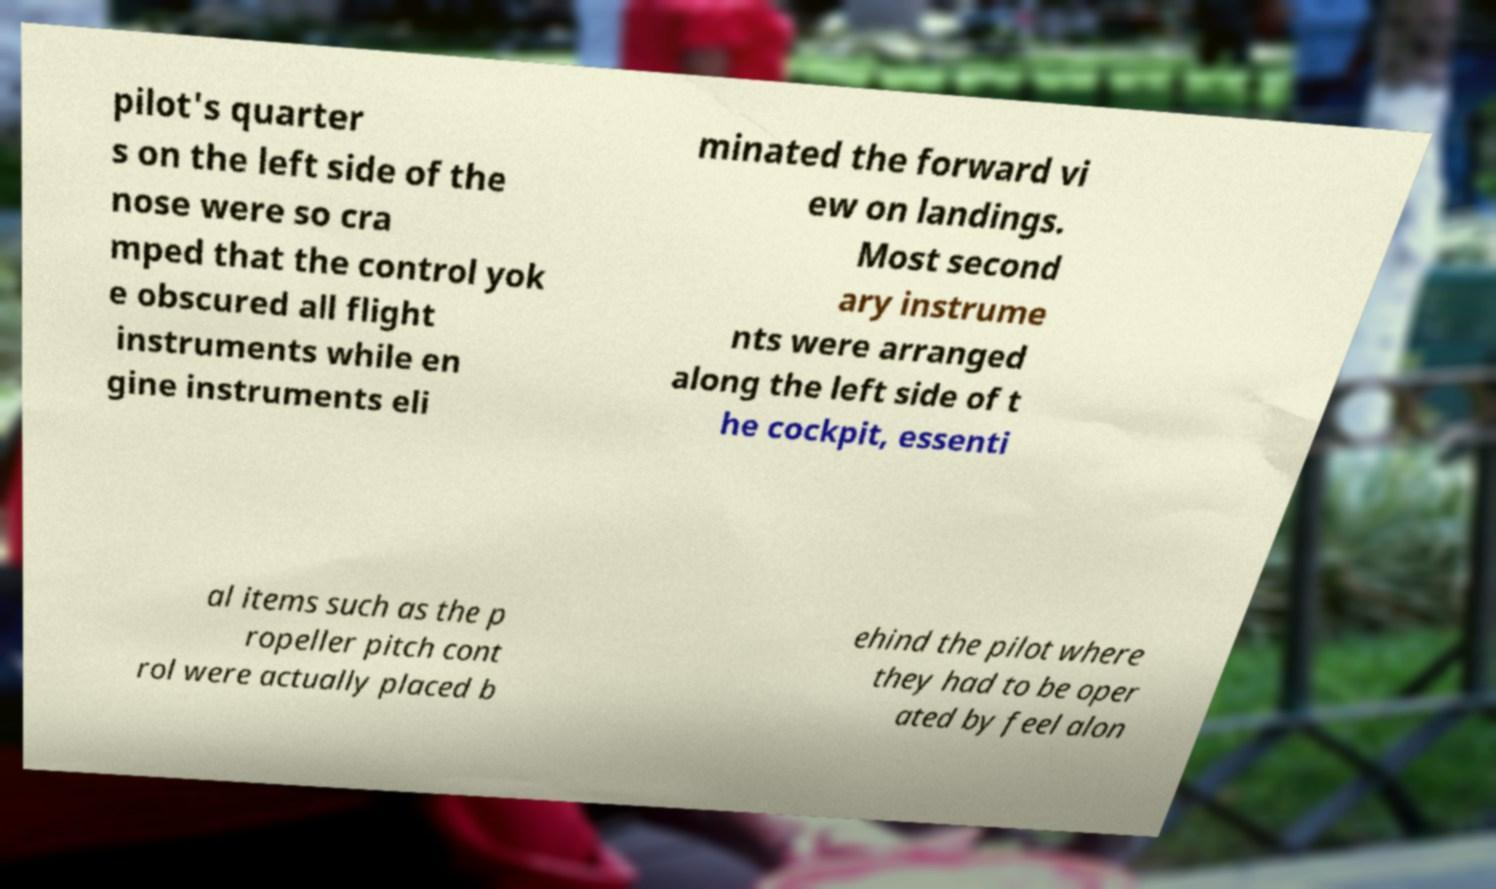Could you extract and type out the text from this image? pilot's quarter s on the left side of the nose were so cra mped that the control yok e obscured all flight instruments while en gine instruments eli minated the forward vi ew on landings. Most second ary instrume nts were arranged along the left side of t he cockpit, essenti al items such as the p ropeller pitch cont rol were actually placed b ehind the pilot where they had to be oper ated by feel alon 